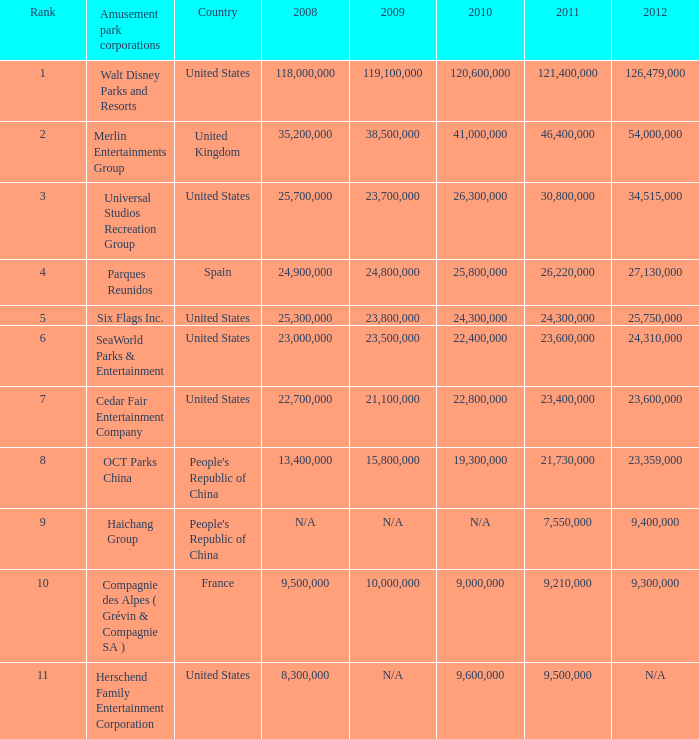For attendances of 9,000,000 in 2010 and over 9,210,000 in 2011, what are their respective ranks? None. 